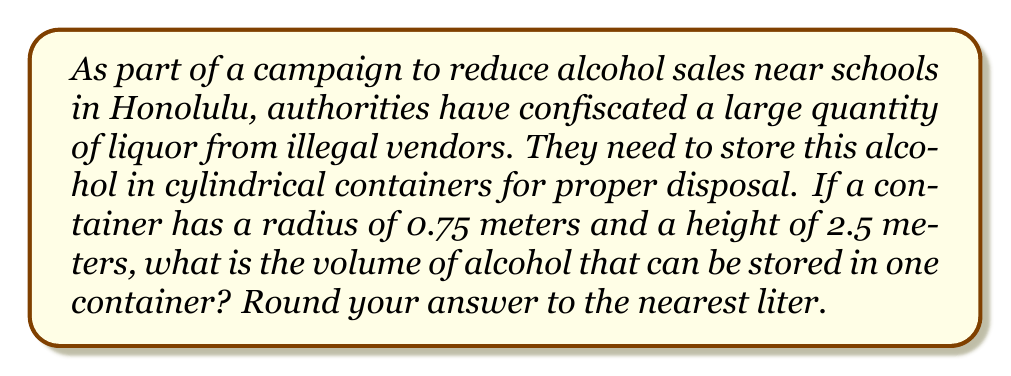Teach me how to tackle this problem. To solve this problem, we need to use the formula for the volume of a cylinder:

$$V = \pi r^2 h$$

Where:
$V$ = volume of the cylinder
$\pi$ = pi (approximately 3.14159)
$r$ = radius of the base of the cylinder
$h$ = height of the cylinder

Given:
$r = 0.75$ meters
$h = 2.5$ meters

Let's substitute these values into the formula:

$$V = \pi (0.75\text{ m})^2 (2.5\text{ m})$$

Now, let's calculate step by step:

1) First, calculate $r^2$:
   $$(0.75\text{ m})^2 = 0.5625\text{ m}^2$$

2) Multiply by $\pi$:
   $$\pi \cdot 0.5625\text{ m}^2 \approx 1.7671\text{ m}^2$$

3) Multiply by the height:
   $$1.7671\text{ m}^2 \cdot 2.5\text{ m} \approx 4.4178\text{ m}^3$$

4) Convert cubic meters to liters:
   1 cubic meter = 1000 liters
   $$4.4178\text{ m}^3 \cdot 1000\text{ L/m}^3 = 4417.8\text{ L}$$

5) Round to the nearest liter:
   4418 L

Therefore, the volume of alcohol that can be stored in one container is approximately 4418 liters.
Answer: 4418 liters 